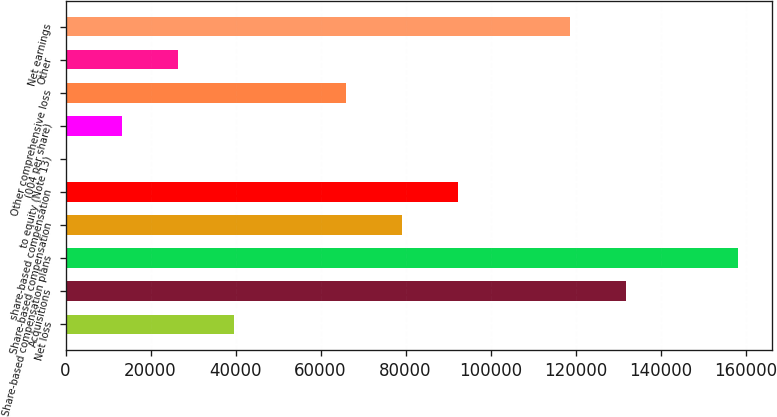Convert chart to OTSL. <chart><loc_0><loc_0><loc_500><loc_500><bar_chart><fcel>Net loss<fcel>Acquisitions<fcel>Share-based compensation plans<fcel>Share-based compensation<fcel>share-based compensation<fcel>to equity (Note 13)<fcel>(004 per share)<fcel>Other comprehensive loss<fcel>Other<fcel>Net earnings<nl><fcel>39572.4<fcel>131907<fcel>158288<fcel>79144.4<fcel>92335<fcel>0.48<fcel>13191.1<fcel>65953.7<fcel>26381.8<fcel>118716<nl></chart> 